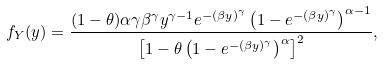<formula> <loc_0><loc_0><loc_500><loc_500>f _ { Y } ( y ) = \frac { ( 1 - \theta ) \alpha \gamma \beta ^ { \gamma } y ^ { \gamma - 1 } e ^ { - ( \beta y ) ^ { \gamma } } \left ( 1 - e ^ { - ( \beta y ) ^ { \gamma } } \right ) ^ { \alpha - 1 } } { \left [ 1 - \theta \left ( 1 - e ^ { - ( \beta y ) ^ { \gamma } } \right ) ^ { \alpha } \right ] ^ { 2 } } ,</formula> 